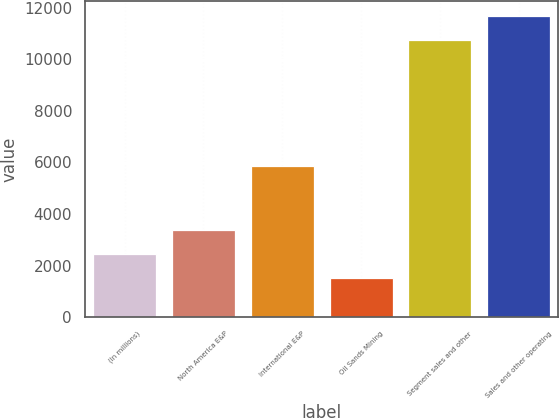Convert chart. <chart><loc_0><loc_0><loc_500><loc_500><bar_chart><fcel>(In millions)<fcel>North America E&P<fcel>International E&P<fcel>Oil Sands Mining<fcel>Segment sales and other<fcel>Sales and other operating<nl><fcel>2456.5<fcel>3378<fcel>5851<fcel>1535<fcel>10750<fcel>11671.5<nl></chart> 